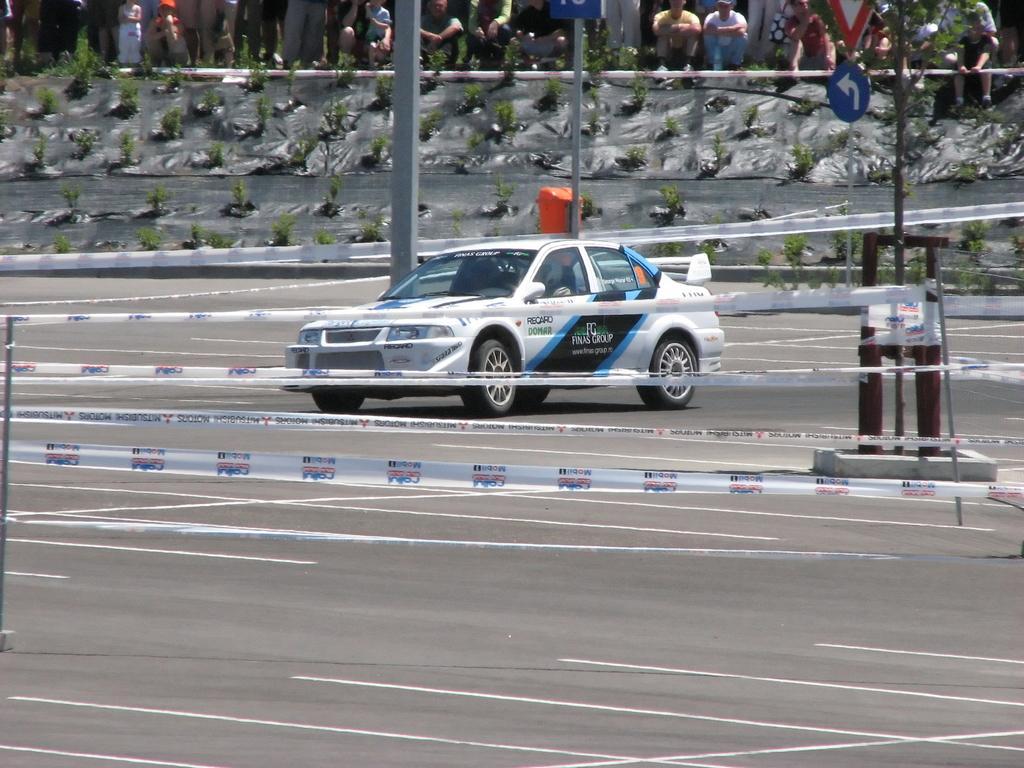In one or two sentences, can you explain what this image depicts? In this picture there is a sports car in the center of the image and there are ribbons around the car and there are people at the top side of the image, there is a sign pole on the right side of the image and there are plants in the image. 